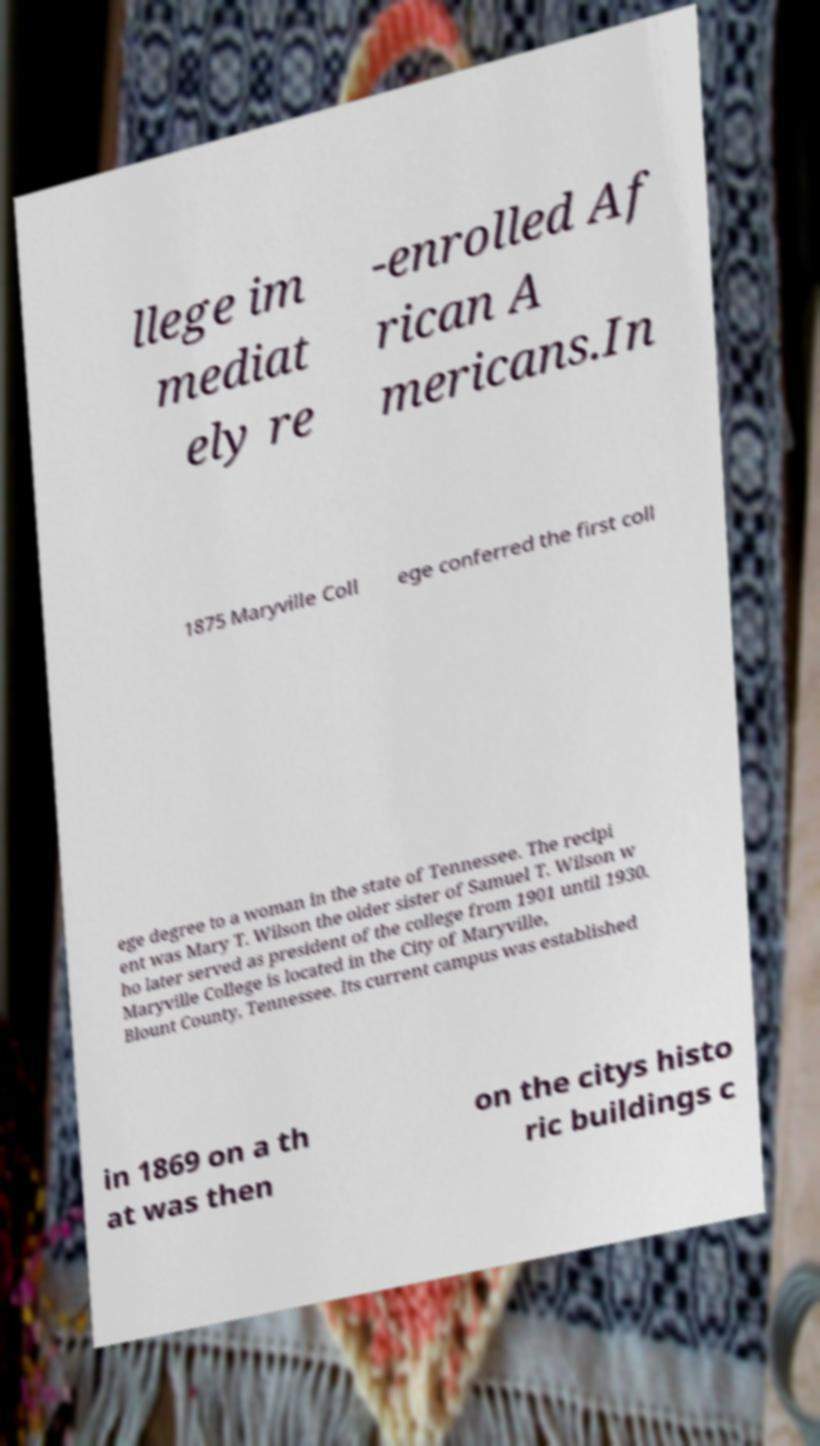Could you assist in decoding the text presented in this image and type it out clearly? llege im mediat ely re -enrolled Af rican A mericans.In 1875 Maryville Coll ege conferred the first coll ege degree to a woman in the state of Tennessee. The recipi ent was Mary T. Wilson the older sister of Samuel T. Wilson w ho later served as president of the college from 1901 until 1930. Maryville College is located in the City of Maryville, Blount County, Tennessee. Its current campus was established in 1869 on a th at was then on the citys histo ric buildings c 